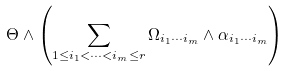<formula> <loc_0><loc_0><loc_500><loc_500>\Theta \wedge \left ( \sum _ { 1 \leq i _ { 1 } < \cdots < i _ { m } \leq r } \Omega _ { i _ { 1 } \cdots i _ { m } } \wedge \alpha _ { i _ { 1 } \cdots i _ { m } } \right )</formula> 